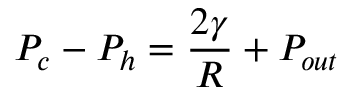Convert formula to latex. <formula><loc_0><loc_0><loc_500><loc_500>P _ { c } - P _ { h } = \frac { 2 \gamma } { R } + P _ { o u t }</formula> 